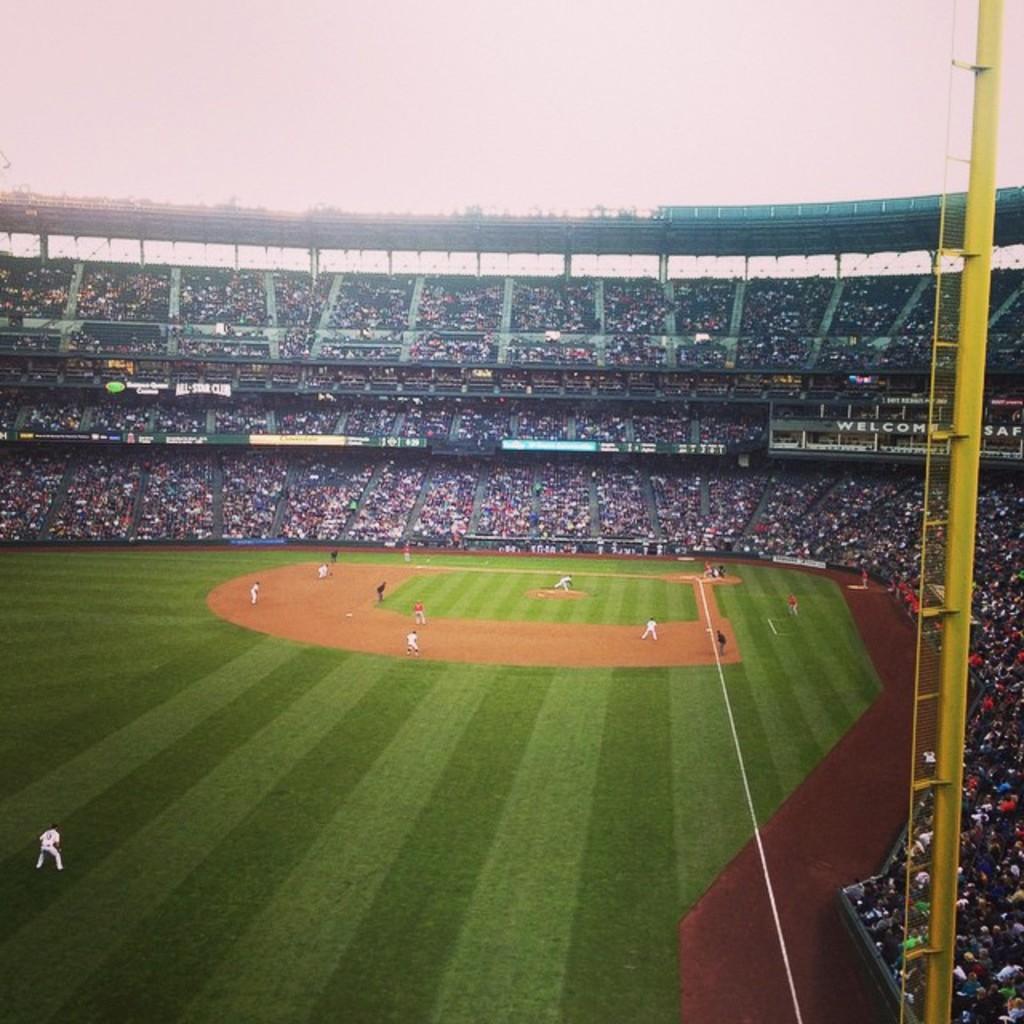In one or two sentences, can you explain what this image depicts? There are few people standing in ground and there are audience in the background. 